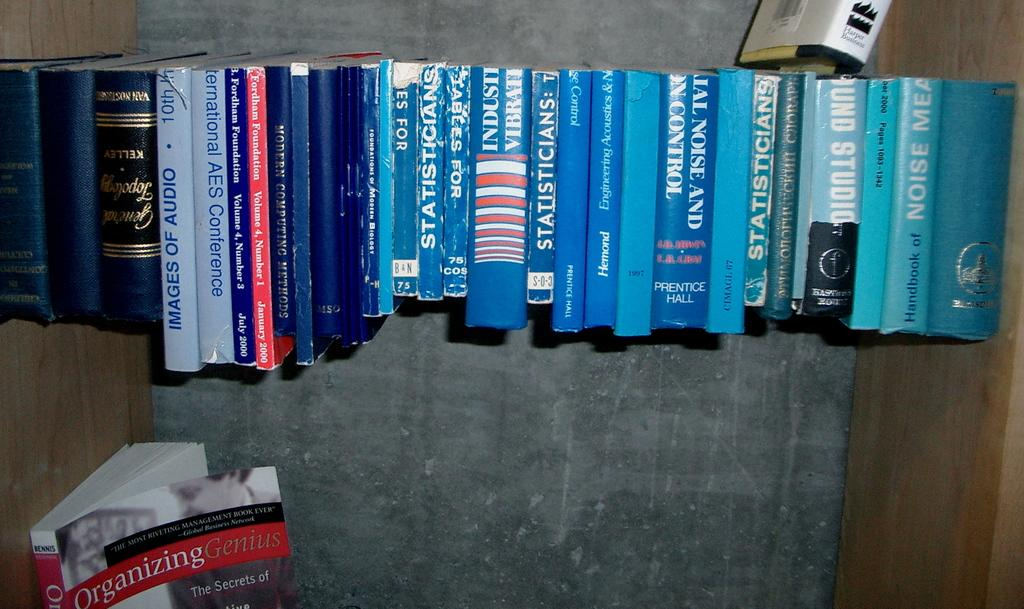<image>
Share a concise interpretation of the image provided. the word Noise is on the blue book 